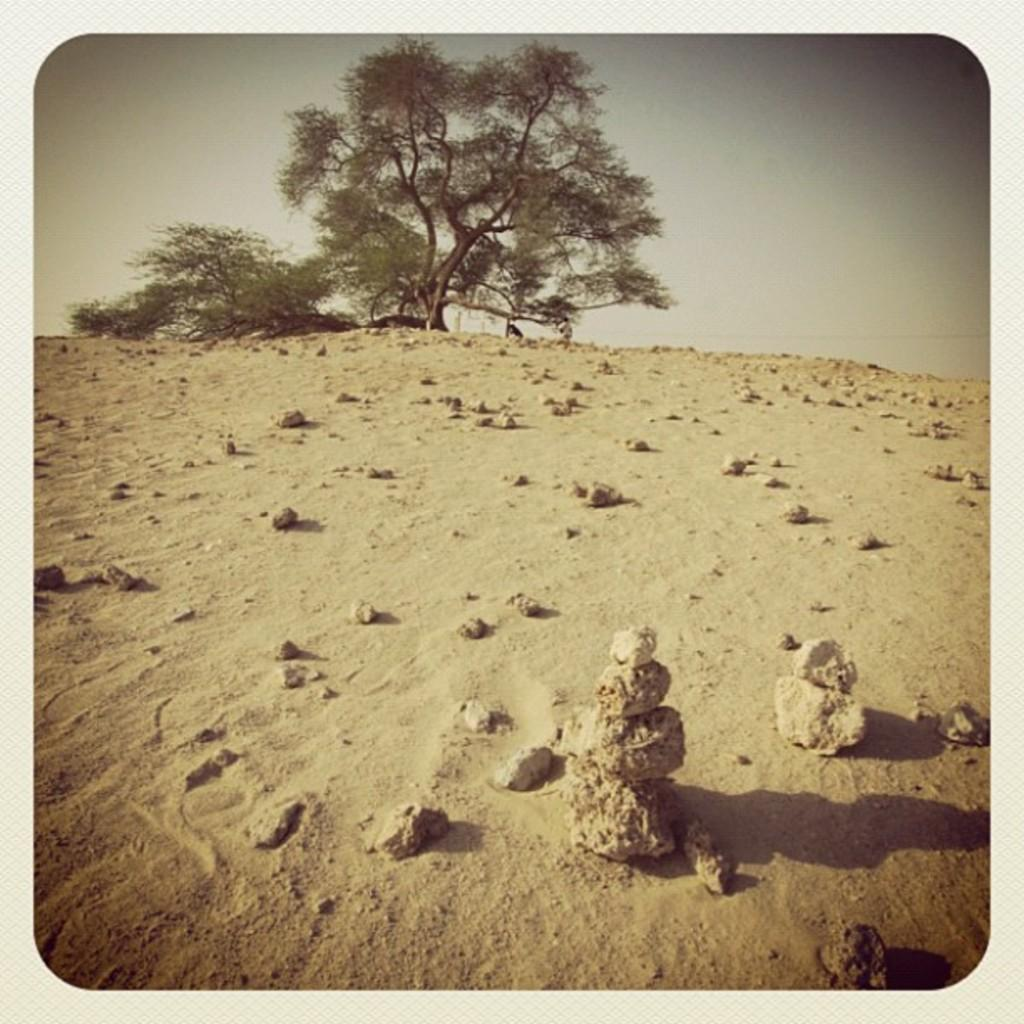What is at the bottom of the image? There is sand and rocks at the bottom of the image. What can be seen in the background of the image? There are trees in the background of the image. What is visible at the top of the image? The sky is visible at the top of the image. Where is the shop located in the image? There is no shop present in the image. Can you see any crackers in the image? There are no crackers present in the image. 